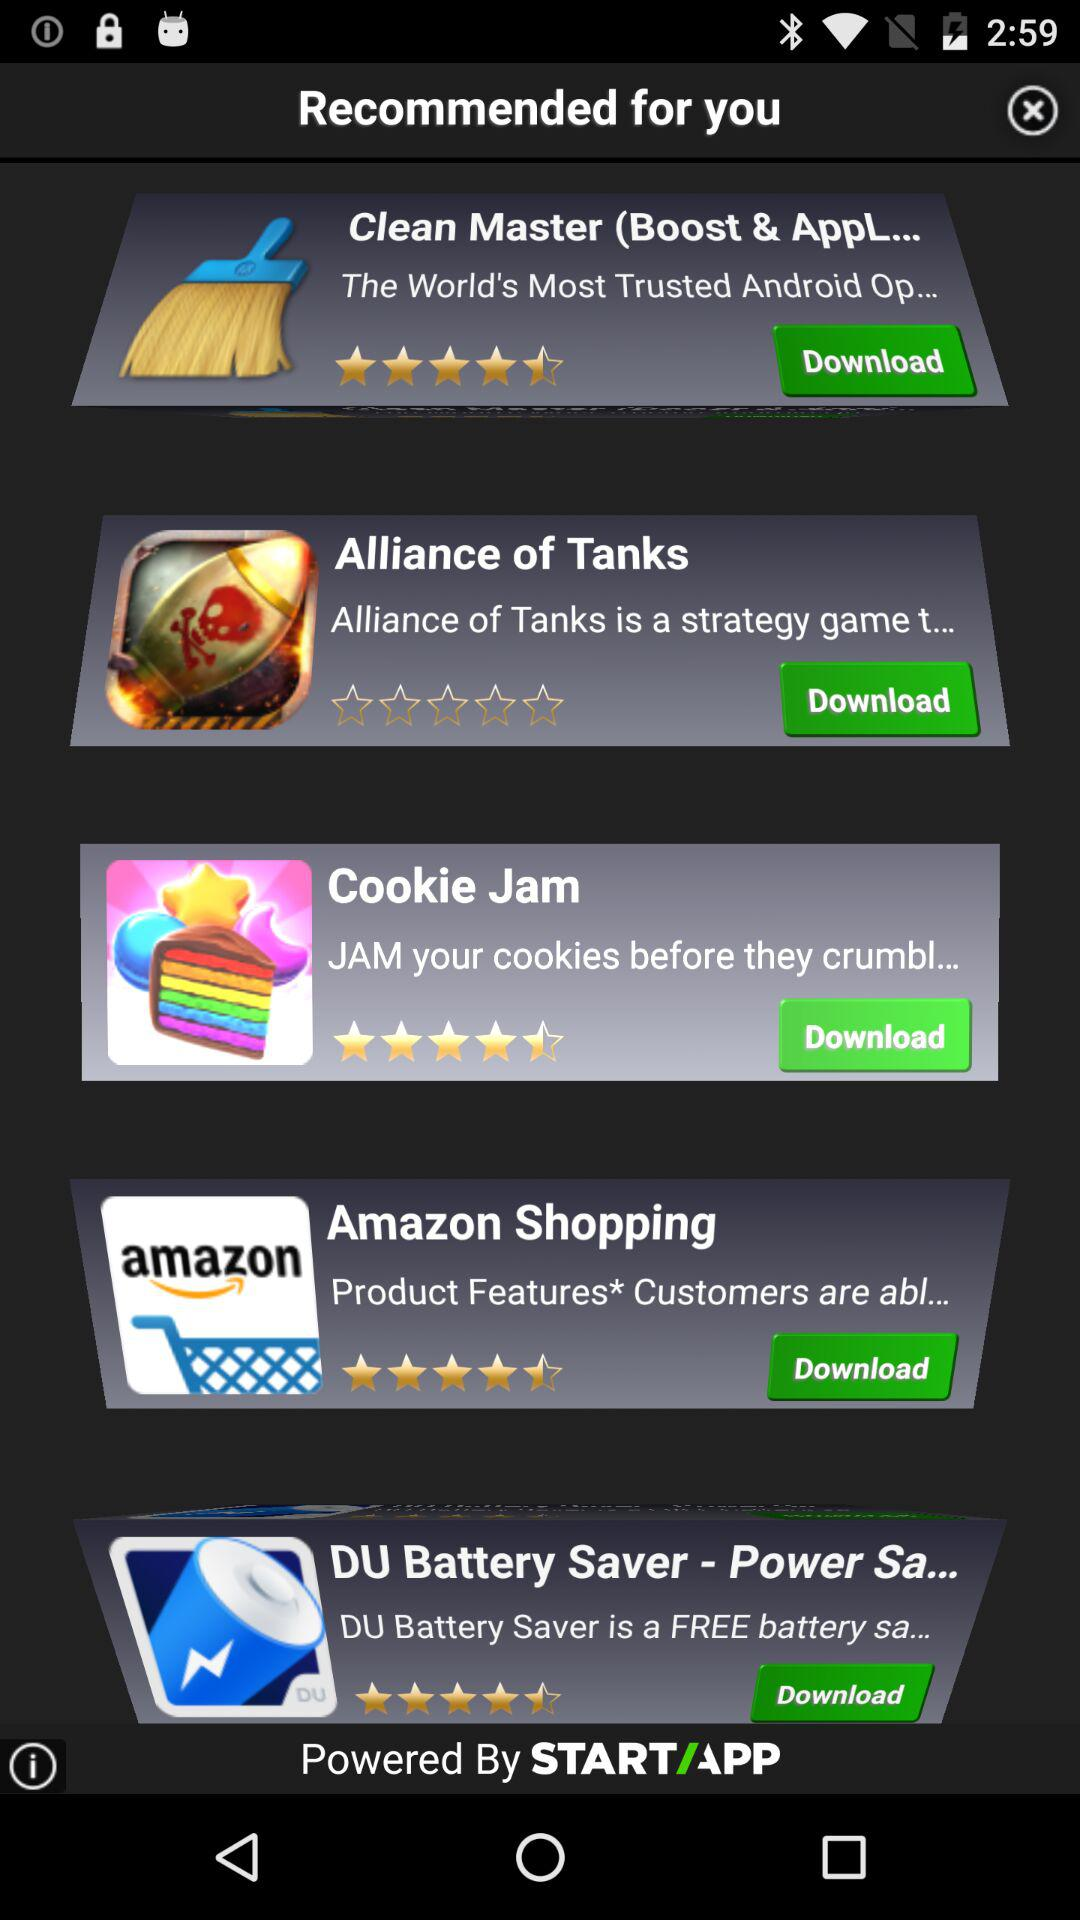What is the rating for the "DU Battery Saver - Power Sa..."? The rating is 4.5 stars. 